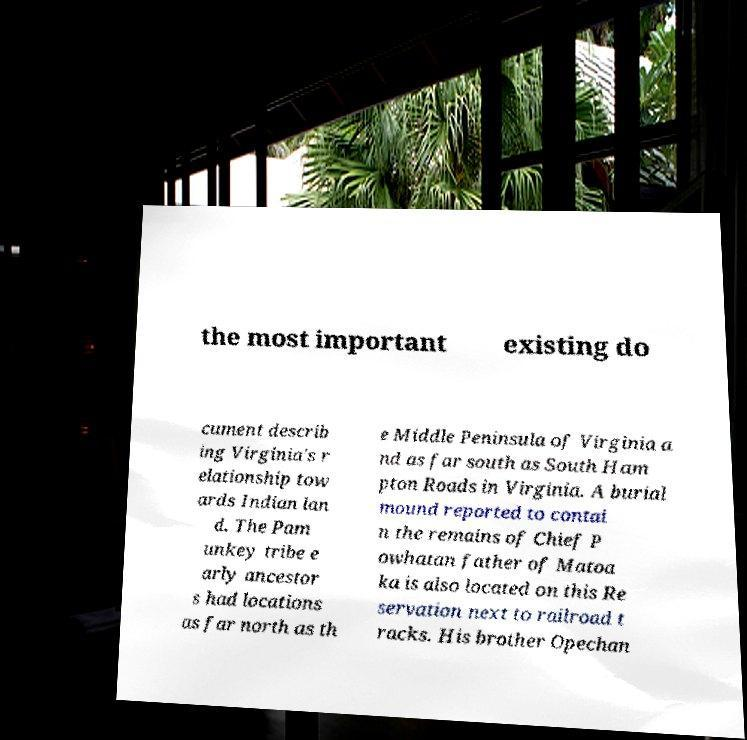Can you accurately transcribe the text from the provided image for me? the most important existing do cument describ ing Virginia's r elationship tow ards Indian lan d. The Pam unkey tribe e arly ancestor s had locations as far north as th e Middle Peninsula of Virginia a nd as far south as South Ham pton Roads in Virginia. A burial mound reported to contai n the remains of Chief P owhatan father of Matoa ka is also located on this Re servation next to railroad t racks. His brother Opechan 